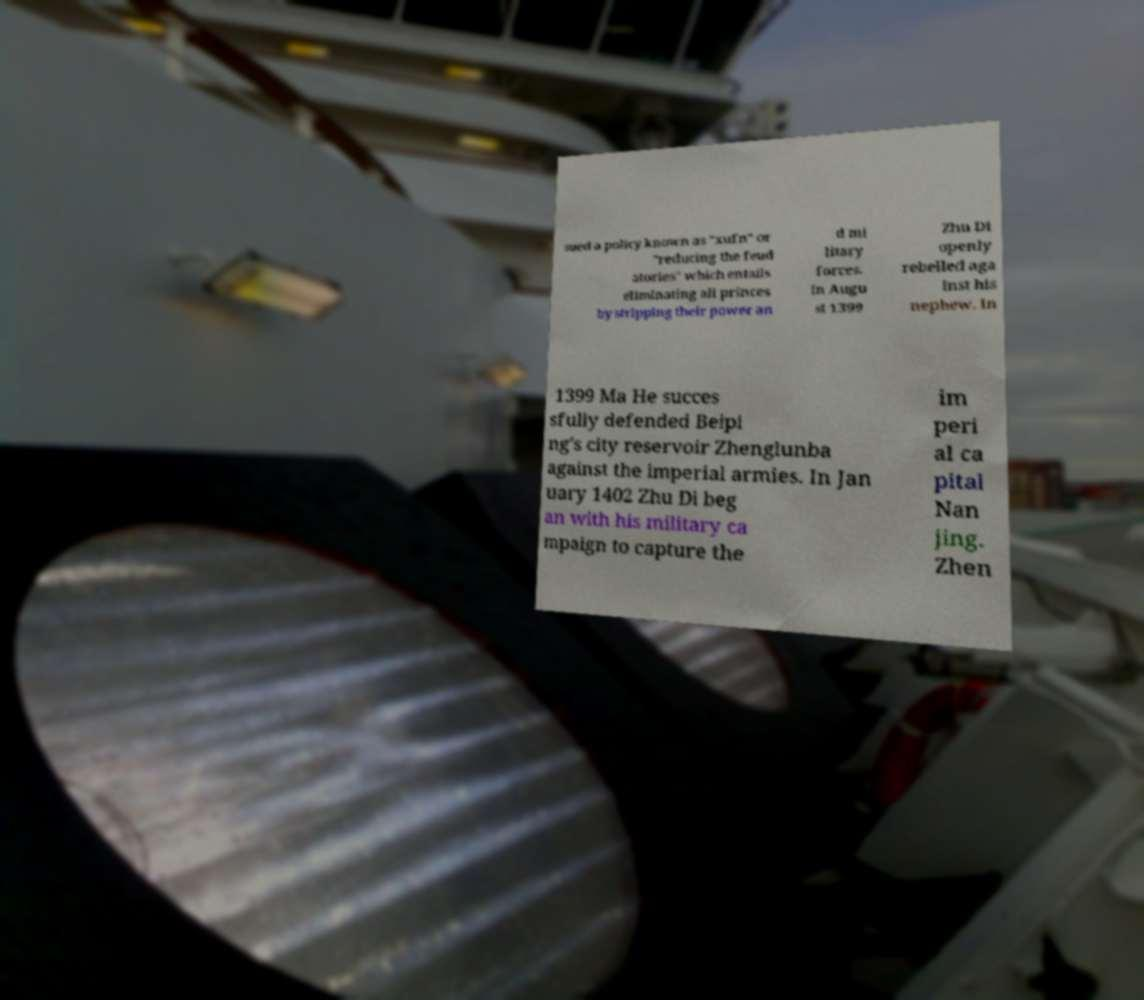There's text embedded in this image that I need extracted. Can you transcribe it verbatim? sued a policy known as "xufn" or "reducing the feud atories" which entails eliminating all princes by stripping their power an d mi litary forces. In Augu st 1399 Zhu Di openly rebelled aga inst his nephew. In 1399 Ma He succes sfully defended Beipi ng's city reservoir Zhenglunba against the imperial armies. In Jan uary 1402 Zhu Di beg an with his military ca mpaign to capture the im peri al ca pital Nan jing. Zhen 